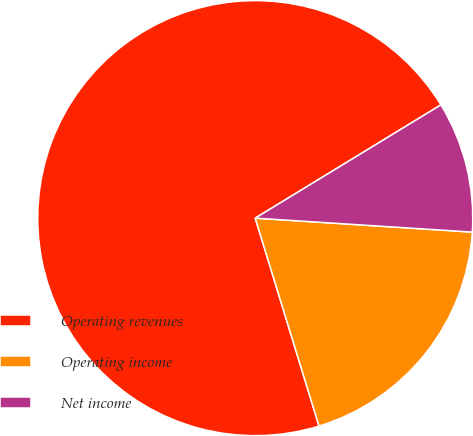Convert chart. <chart><loc_0><loc_0><loc_500><loc_500><pie_chart><fcel>Operating revenues<fcel>Operating income<fcel>Net income<nl><fcel>71.02%<fcel>19.24%<fcel>9.74%<nl></chart> 